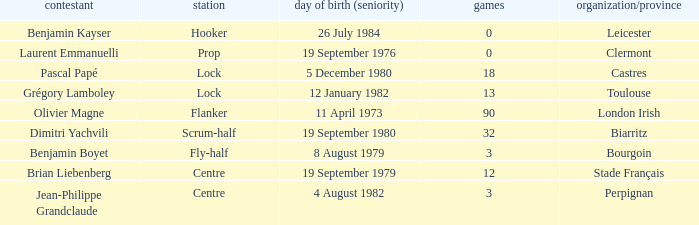Which player has a cap larger than 12 and Clubs of Toulouse? Grégory Lamboley. 